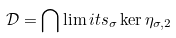<formula> <loc_0><loc_0><loc_500><loc_500>\mathcal { D } = \bigcap \lim i t s _ { \sigma } \ker \eta _ { \sigma , 2 }</formula> 